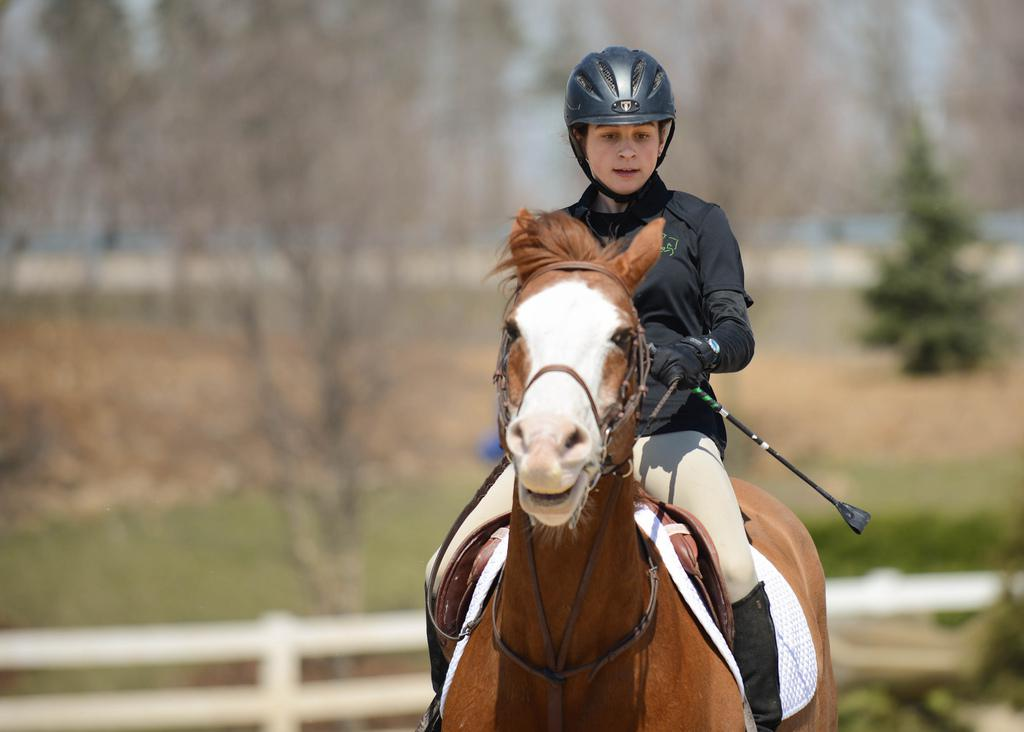Question: what direction is the lady looking?
Choices:
A. Down.
B. Up.
C. South.
D. Towards to sea.
Answer with the letter. Answer: A Question: where is the girl?
Choices:
A. On a horse.
B. On a bicycle.
C. On a skateboard.
D. In a car.
Answer with the letter. Answer: A Question: what is in the girl's hand?
Choices:
A. A feed bag.
B. A horse crop.
C. A lasso.
D. A saddle.
Answer with the letter. Answer: B Question: what color are her pants?
Choices:
A. Green.
B. Lavender.
C. Peach.
D. Beige.
Answer with the letter. Answer: D Question: what color is the sky?
Choices:
A. The sky is blue.
B. Orange.
C. Yellow.
D. Red.
Answer with the letter. Answer: A Question: where is the white blanket?
Choices:
A. On the horse.
B. On the ground.
C. On the bench.
D. In the house.
Answer with the letter. Answer: A Question: what does the horse look like?
Choices:
A. Black with a shiny black mane.
B. White with brown spots.
C. The horse is brown with a white nose.
D. Brown with grey and white patches.
Answer with the letter. Answer: C Question: who is wearing a black helmet?
Choices:
A. The current rider.
B. The young rider.
C. All riders.
D. The boys.
Answer with the letter. Answer: B Question: what color is the fence?
Choices:
A. It is black.
B. It is blue.
C. It is white.
D. It is green.
Answer with the letter. Answer: C Question: what is behind the horse?
Choices:
A. Green and brown grass.
B. A cart.
C. A plow.
D. The other horses.
Answer with the letter. Answer: A Question: how is the girl sitting?
Choices:
A. She is slumped over.
B. She is sitting up straight.
C. She is sitting sideways.
D. She is leaning back.
Answer with the letter. Answer: B Question: where is the girl on the horse looking?
Choices:
A. Towards the sunset.
B. Across the water.
C. Down.
D. Up.
Answer with the letter. Answer: C Question: what does the horse have on?
Choices:
A. A blanket.
B. A woman.
C. A saddle.
D. All its riding equipment.
Answer with the letter. Answer: D 